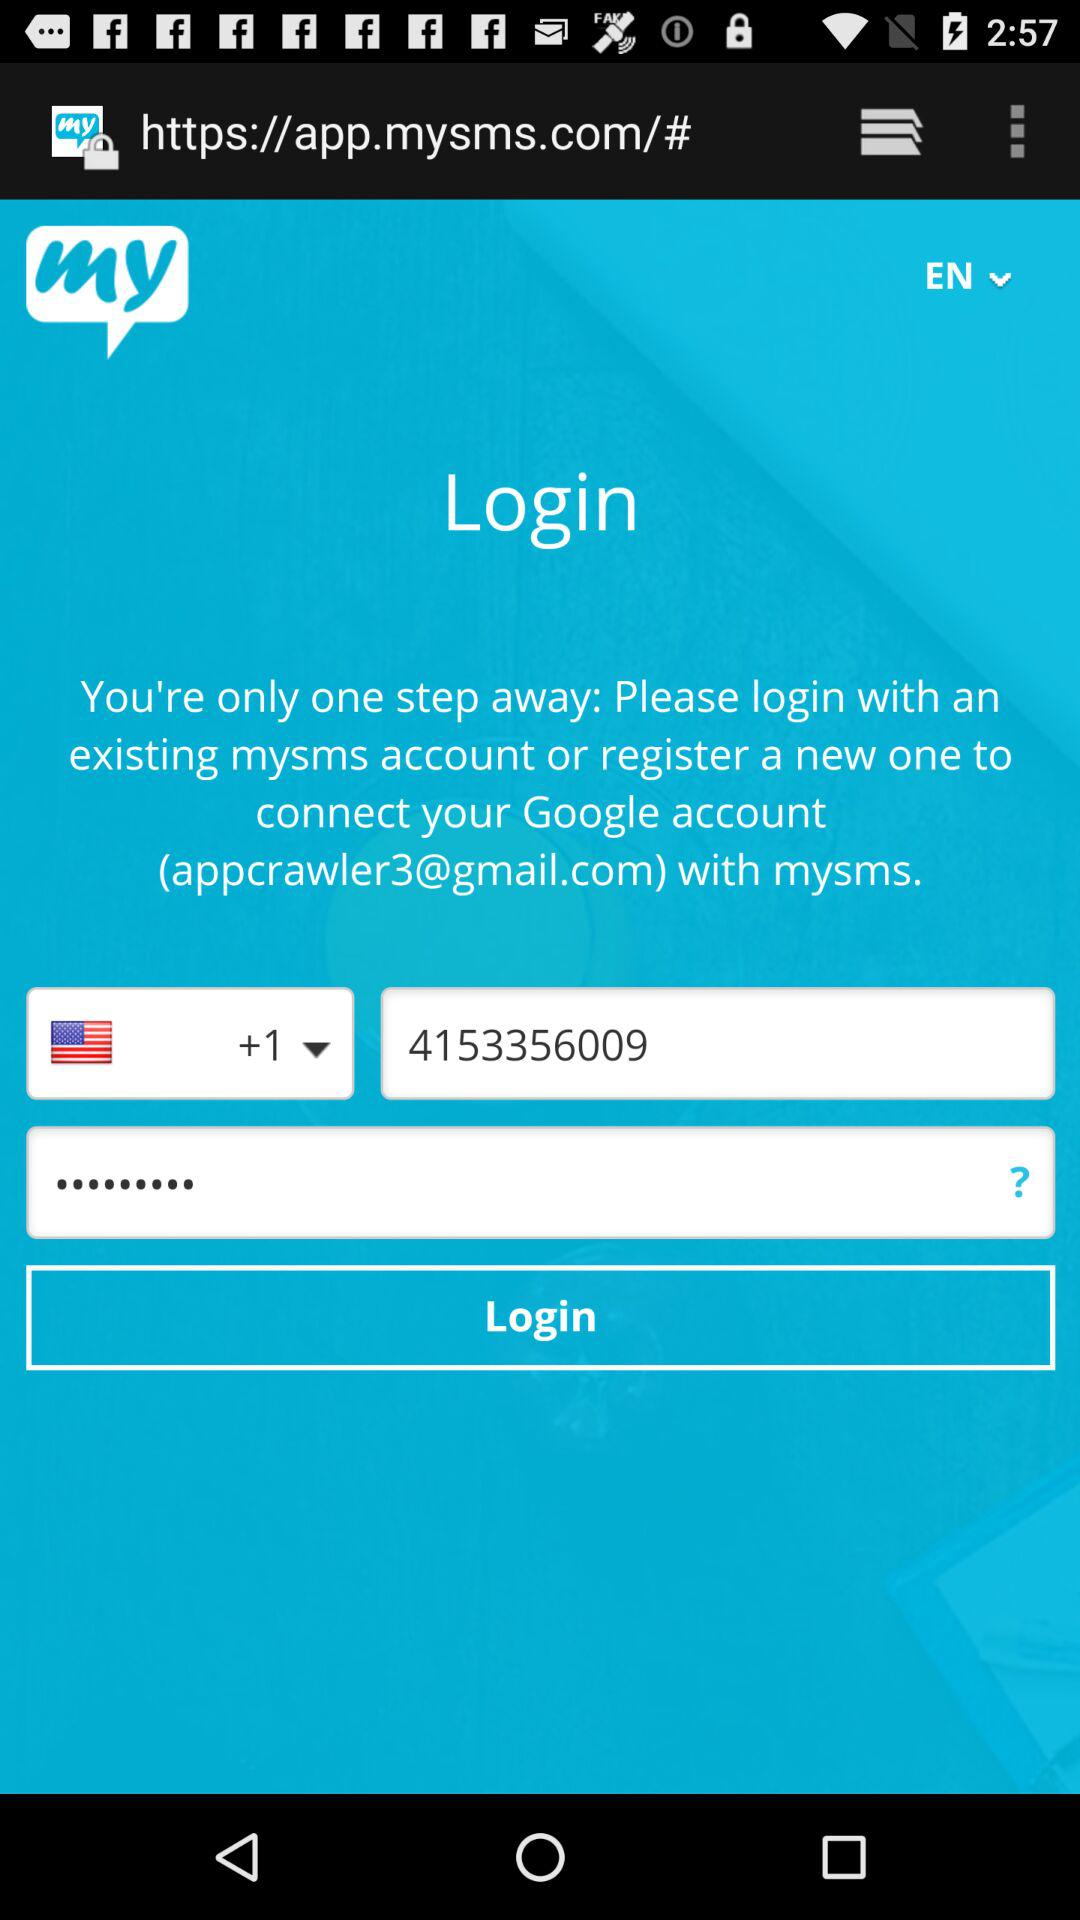What is the email address? The email address is appcrawler3@gmail.com. 